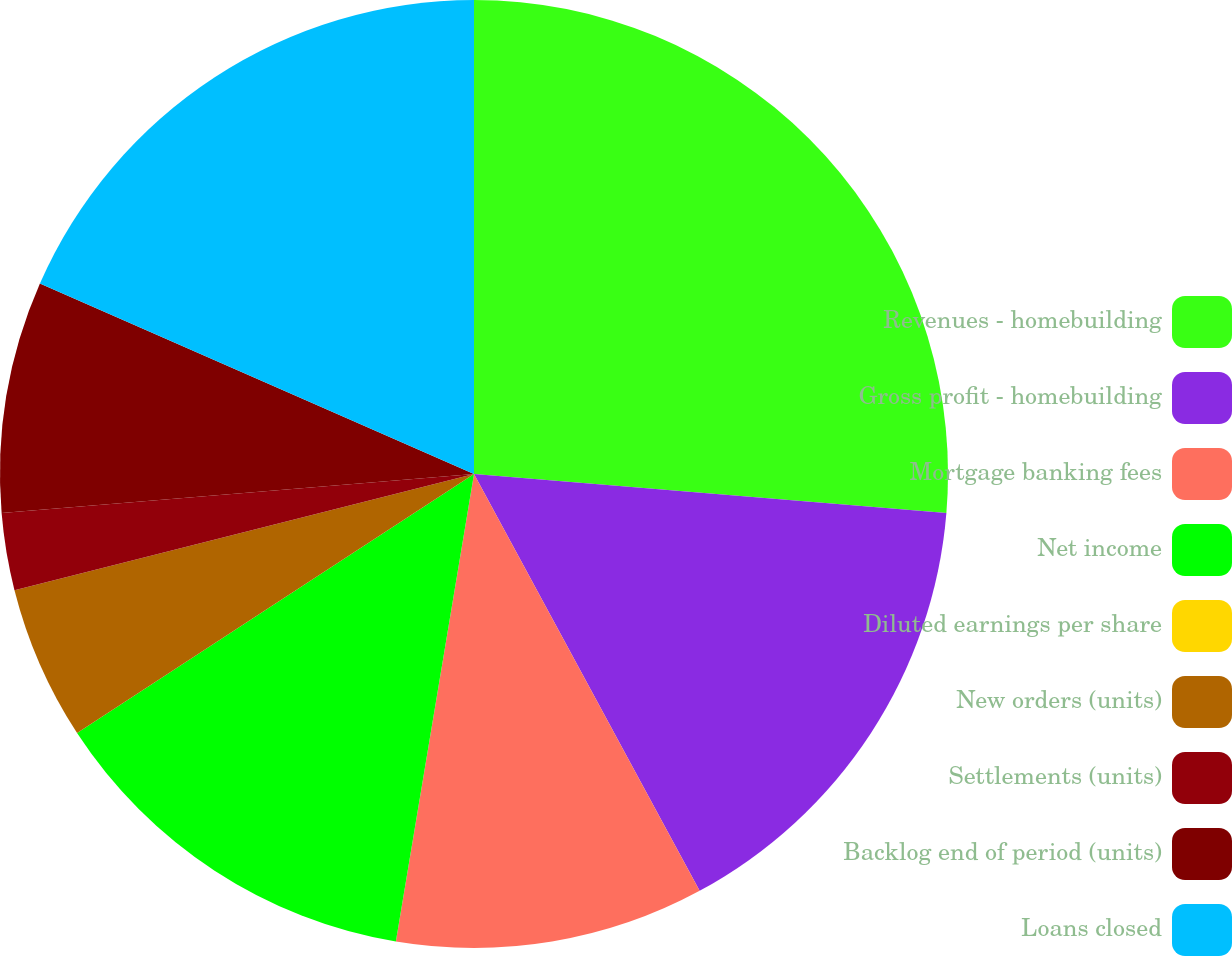Convert chart to OTSL. <chart><loc_0><loc_0><loc_500><loc_500><pie_chart><fcel>Revenues - homebuilding<fcel>Gross profit - homebuilding<fcel>Mortgage banking fees<fcel>Net income<fcel>Diluted earnings per share<fcel>New orders (units)<fcel>Settlements (units)<fcel>Backlog end of period (units)<fcel>Loans closed<nl><fcel>26.31%<fcel>15.79%<fcel>10.53%<fcel>13.16%<fcel>0.0%<fcel>5.26%<fcel>2.63%<fcel>7.89%<fcel>18.42%<nl></chart> 